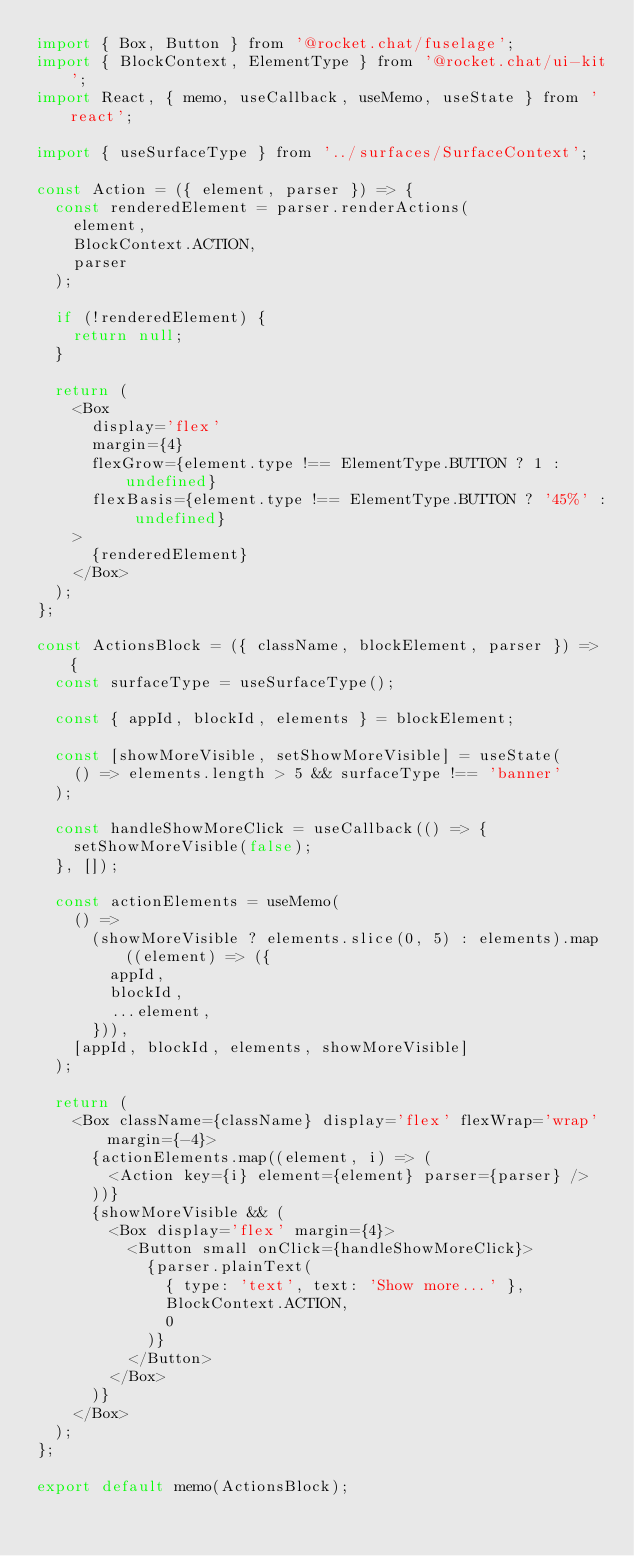<code> <loc_0><loc_0><loc_500><loc_500><_JavaScript_>import { Box, Button } from '@rocket.chat/fuselage';
import { BlockContext, ElementType } from '@rocket.chat/ui-kit';
import React, { memo, useCallback, useMemo, useState } from 'react';

import { useSurfaceType } from '../surfaces/SurfaceContext';

const Action = ({ element, parser }) => {
  const renderedElement = parser.renderActions(
    element,
    BlockContext.ACTION,
    parser
  );

  if (!renderedElement) {
    return null;
  }

  return (
    <Box
      display='flex'
      margin={4}
      flexGrow={element.type !== ElementType.BUTTON ? 1 : undefined}
      flexBasis={element.type !== ElementType.BUTTON ? '45%' : undefined}
    >
      {renderedElement}
    </Box>
  );
};

const ActionsBlock = ({ className, blockElement, parser }) => {
  const surfaceType = useSurfaceType();

  const { appId, blockId, elements } = blockElement;

  const [showMoreVisible, setShowMoreVisible] = useState(
    () => elements.length > 5 && surfaceType !== 'banner'
  );

  const handleShowMoreClick = useCallback(() => {
    setShowMoreVisible(false);
  }, []);

  const actionElements = useMemo(
    () =>
      (showMoreVisible ? elements.slice(0, 5) : elements).map((element) => ({
        appId,
        blockId,
        ...element,
      })),
    [appId, blockId, elements, showMoreVisible]
  );

  return (
    <Box className={className} display='flex' flexWrap='wrap' margin={-4}>
      {actionElements.map((element, i) => (
        <Action key={i} element={element} parser={parser} />
      ))}
      {showMoreVisible && (
        <Box display='flex' margin={4}>
          <Button small onClick={handleShowMoreClick}>
            {parser.plainText(
              { type: 'text', text: 'Show more...' },
              BlockContext.ACTION,
              0
            )}
          </Button>
        </Box>
      )}
    </Box>
  );
};

export default memo(ActionsBlock);
</code> 